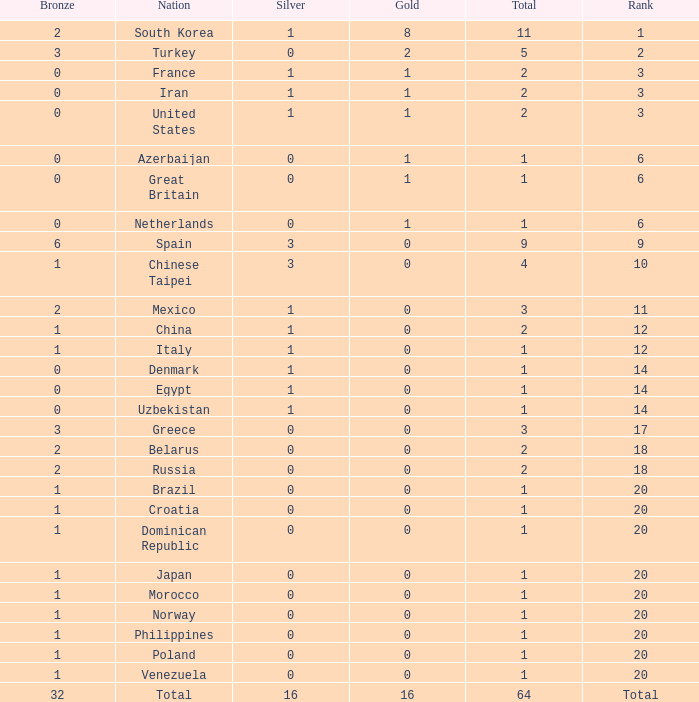What is the average number of bronze of the nation with more than 1 gold and 1 silver medal? 2.0. 